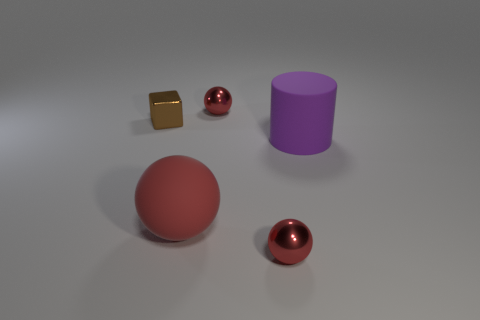How many other things are the same size as the brown metal thing?
Your answer should be compact. 2. Do the metal object that is behind the small brown shiny thing and the tiny brown object have the same shape?
Keep it short and to the point. No. Are there fewer big matte cylinders that are behind the brown block than small brown things?
Your response must be concise. Yes. Are there any tiny metal things of the same color as the big cylinder?
Your answer should be very brief. No. There is a purple object; does it have the same shape as the shiny thing that is behind the block?
Provide a short and direct response. No. Is there another small brown object that has the same material as the tiny brown object?
Offer a terse response. No. There is a red metal ball that is in front of the small red metal object behind the purple cylinder; are there any big red things that are on the right side of it?
Offer a terse response. No. How many other things are there of the same shape as the tiny brown thing?
Ensure brevity in your answer.  0. What is the color of the metallic object on the left side of the small red object that is behind the small object in front of the large red matte object?
Make the answer very short. Brown. How many spheres are there?
Ensure brevity in your answer.  3. 